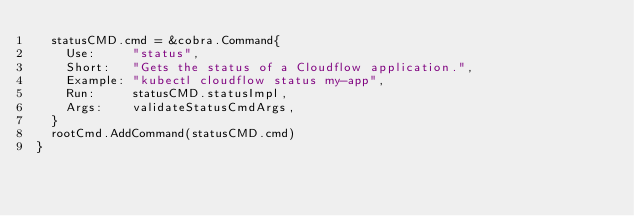<code> <loc_0><loc_0><loc_500><loc_500><_Go_>	statusCMD.cmd = &cobra.Command{
		Use:     "status",
		Short:   "Gets the status of a Cloudflow application.",
		Example: "kubectl cloudflow status my-app",
		Run:     statusCMD.statusImpl,
		Args:    validateStatusCmdArgs,
	}
	rootCmd.AddCommand(statusCMD.cmd)
}
</code> 